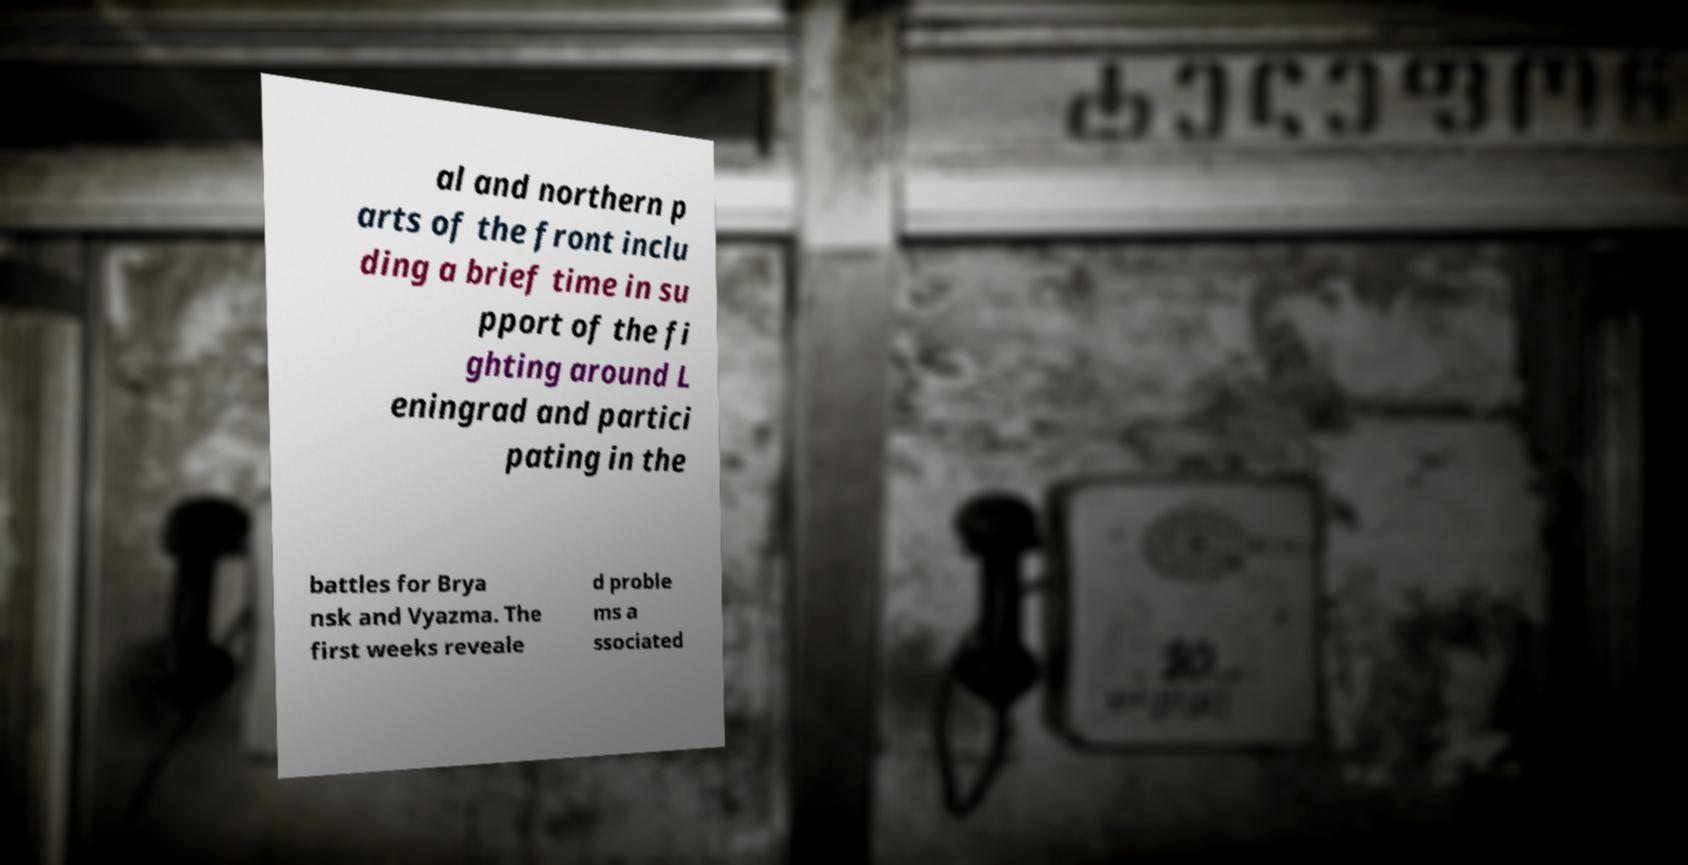I need the written content from this picture converted into text. Can you do that? al and northern p arts of the front inclu ding a brief time in su pport of the fi ghting around L eningrad and partici pating in the battles for Brya nsk and Vyazma. The first weeks reveale d proble ms a ssociated 